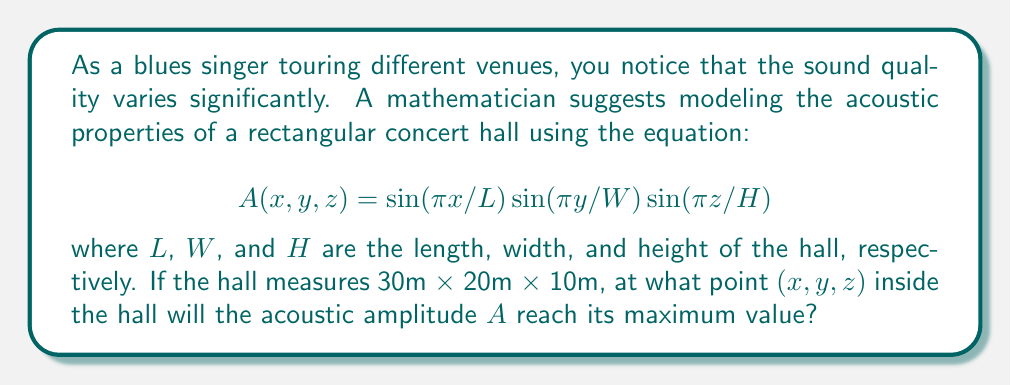Give your solution to this math problem. To find the maximum value of the acoustic amplitude $A$, we need to analyze the sinusoidal functions in the equation:

1) The general form of a sine function is $\sin(\theta)$, which reaches its maximum value of 1 when $\theta = \pi/2, 3\pi/2, 5\pi/2,$ etc.

2) For each dimension:

   $\sin(\pi x/L)$ is maximum when $\pi x/L = \pi/2$, so $x = L/2 = 15$ m
   $\sin(\pi y/W)$ is maximum when $\pi y/W = \pi/2$, so $y = W/2 = 10$ m
   $\sin(\pi z/H)$ is maximum when $\pi z/H = \pi/2$, so $z = H/2 = 5$ m

3) The product of these three sine functions will be at its maximum when each individual function is at its maximum.

4) Therefore, the acoustic amplitude $A$ reaches its maximum at the point (15, 10, 5), which is the center of the concert hall.

5) We can verify this by substituting these values into the original equation:

   $$A(15,10,5) = \sin(\pi 15/30) \sin(\pi 10/20) \sin(\pi 5/10) = \sin(\pi/2) \sin(\pi/2) \sin(\pi/2) = 1 \cdot 1 \cdot 1 = 1$$

This confirms that the amplitude reaches its maximum value of 1 at this point.
Answer: (15, 10, 5) 